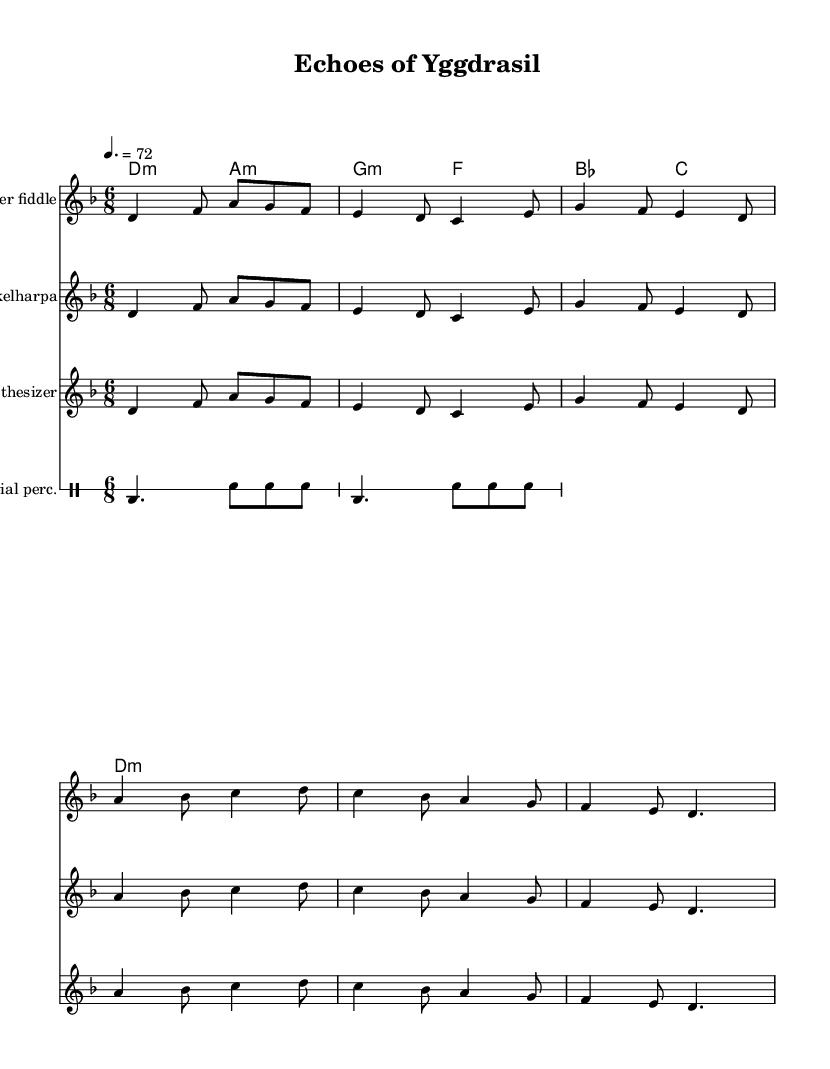What is the key signature of this music? The key signature is determined by the presence of accidentals at the beginning of the staff. In this case, no sharps or flats are indicated, which corresponds to D minor, commonly notated with one flat, but here, it begins with an absence of accidentals, confirming it is indeed in D minor.
Answer: D minor What is the time signature of this composition? The time signature is indicated at the beginning of the music sheet after the key signature. It states "6/8", which means there are six beats in a measure and the eighth note gets one beat.
Answer: 6/8 What is the tempo marking for this piece? The tempo marking, located at the start of the piece, indicates how fast the music should be played. Here, it's set at "4. = 72", signifying that there are 72 beats per minute when counting quarter notes.
Answer: 72 How many instruments are featured in this score? By counting the staffs listed in the score, we observe one staff for each of the three instruments (Hardanger fiddle, Nyckelharpa, and Synthesizer) along with a dedicated staff for the Industrial percussion. Thus, there are four instruments represented in total.
Answer: Four Which chord is played first in the harmony section? The harmony section indicates the chords that will support the melody. The first chord listed in the chord mode is "d4.:m", which designates a D minor chord.
Answer: D minor How many measures are in the main theme? The main theme is comprised of the first two lines of music presented for the Hardanger fiddle, Nyckelharpa, and Synthesizer. Each line contains 4 measures, so two lines give a total of 8 measures.
Answer: 8 Which instrument plays the industrial percussion? In the score, the industrial percussion is indicated by the staff labeled "Industrial perc.", which refers to the unique rhythmic elements included in the piece.
Answer: Industrial percussion 